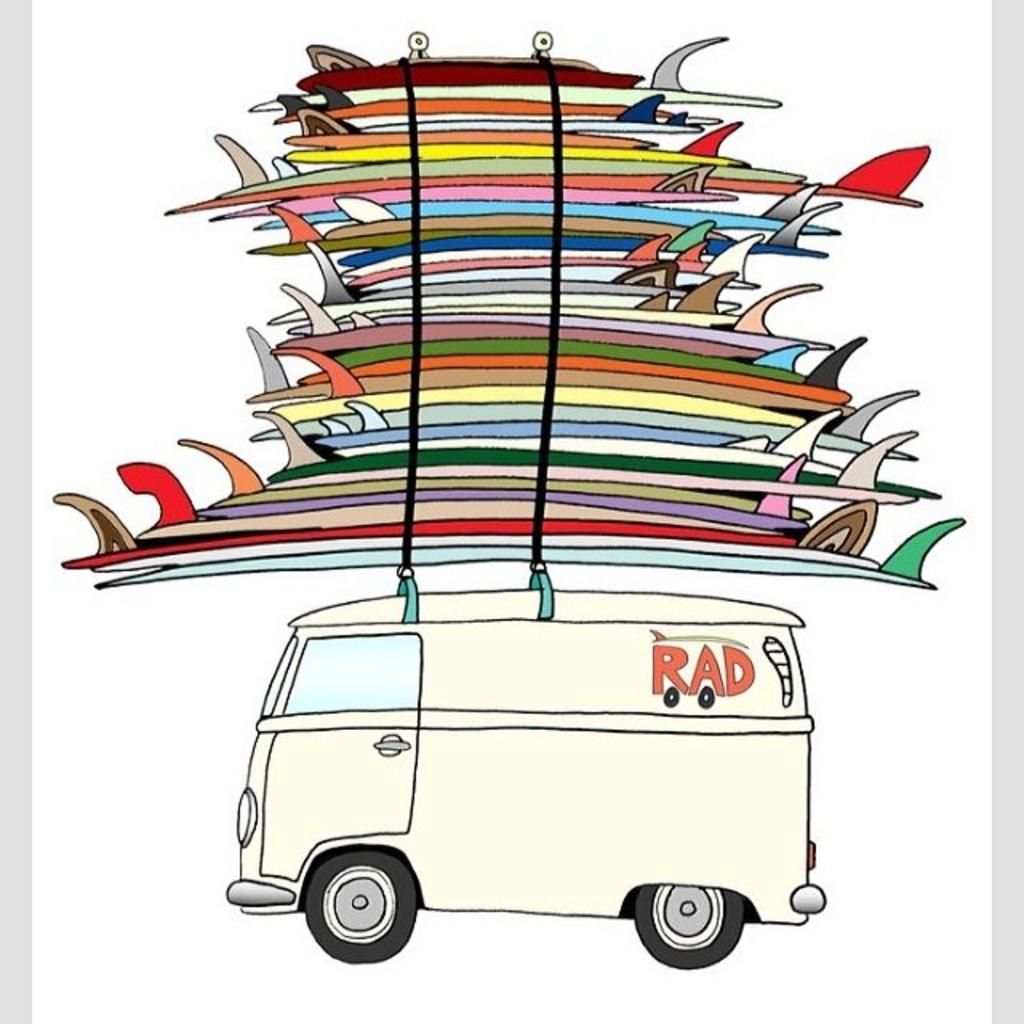What is the main subject in the foreground of the poster? There is a cartoon image of a van in the foreground of the poster. What is attached to the top of the van? Many surfing boards are tied on the top of the van. How many sisters are depicted in the image? There are no sisters depicted in the image; it features a cartoon van with surfing boards on top. What type of power source is used to operate the van in the image? The image is a cartoon, and there is no information about the power source for the van. 